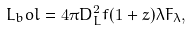<formula> <loc_0><loc_0><loc_500><loc_500>L _ { b } o l = 4 \pi D _ { L } ^ { 2 } f ( 1 + z ) \lambda F _ { \lambda } ,</formula> 